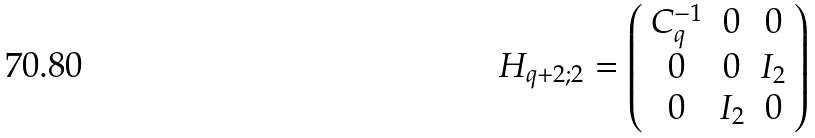<formula> <loc_0><loc_0><loc_500><loc_500>H _ { q + 2 ; 2 } = \left ( \begin{array} { c c c } C _ { q } ^ { - 1 } & 0 & 0 \\ 0 & 0 & I _ { 2 } \\ 0 & I _ { 2 } & 0 \end{array} \right )</formula> 